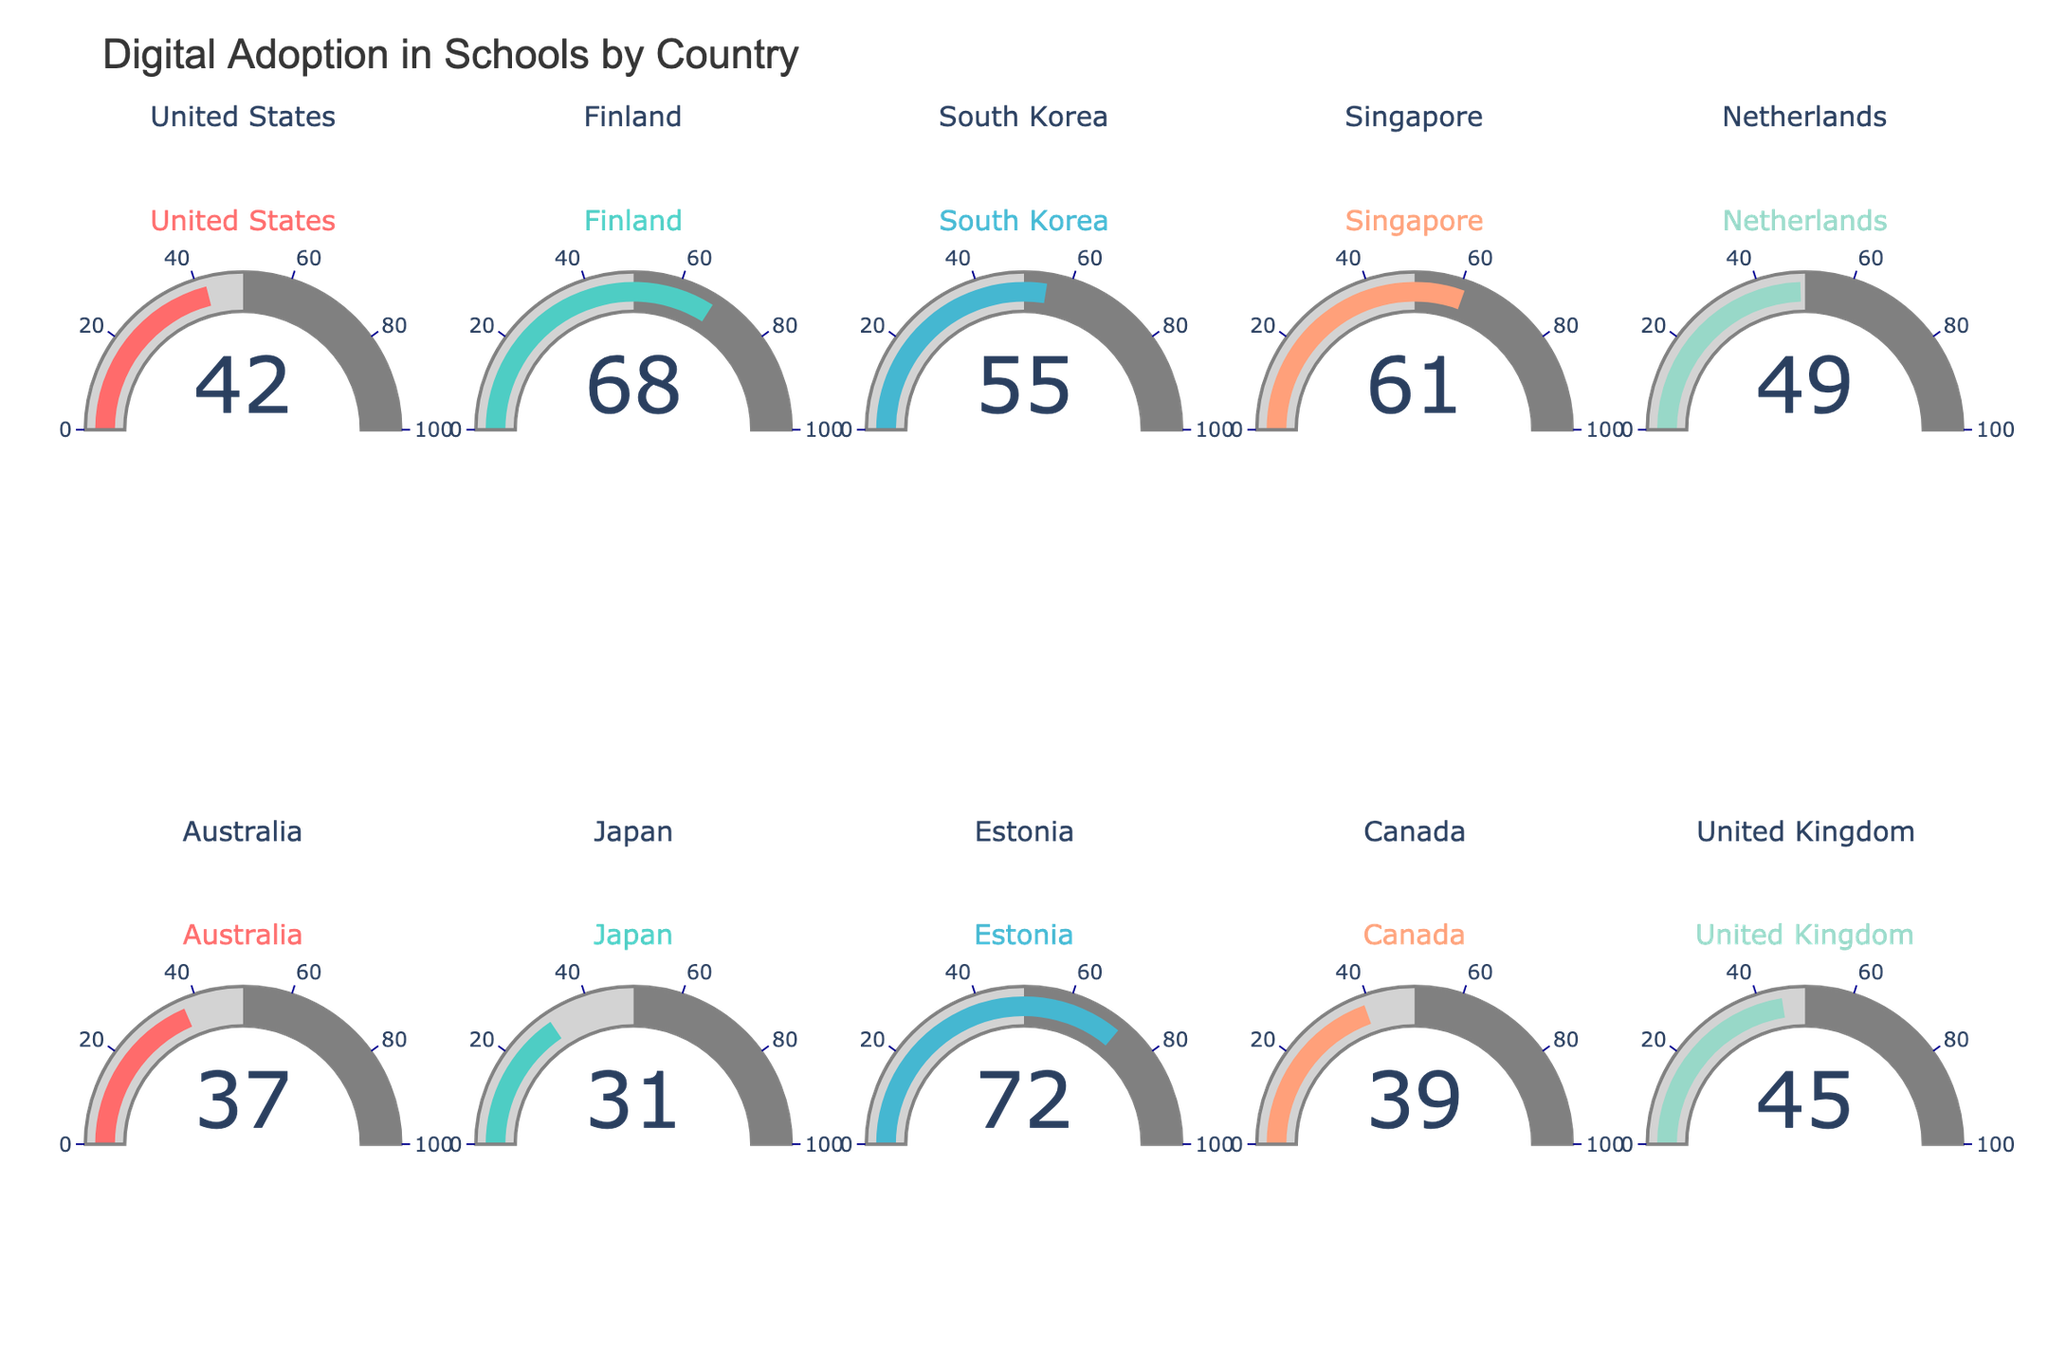What is the percentage of digital adoption in Finland? Look at the gauge for Finland in the figure. The gauge shows the number directly.
Answer: 68% How many countries have more than 50% digital adoption? Identify all countries with a gauge value over 50. Count them: Finland (68), South Korea (55), Singapore (61), Estonia (72). Total = 4
Answer: 4 Which country has the lowest digital adoption rate? Compare values on all gauges. The country with the lowest value is Japan with 31%.
Answer: Japan What is the average digital adoption rate among all the countries? Add up all the digital adoption rates and divide by 10 (total number of countries). (42 + 68 + 55 + 61 + 49 + 37 + 31 + 72 + 39 + 45) / 10 = 499 / 10 = 49.9
Answer: 49.9 Which country has a digital adoption rate closest to 40%? Look at the gauges for values close to 40. Canada has 39%, which is the nearest value.
Answer: Canada What is the difference between the highest and lowest digital adoption rates? Identify highest (Estonia, 72%) and lowest (Japan, 31%). Subtract the two values. 72 - 31 = 41
Answer: 41 How many countries are below the global average rate of digital adoption (49.9%)? Count countries with values less than 49.9: Australia (37), Japan (31), Canada (39). Total = 3.
Answer: 3 Which countries have a digital adoption rate greater than 60%? Identify gauges with values above 60%. Finland (68), Singapore (61), Estonia (72).
Answer: Finland, Singapore, Estonia What is the total sum of digital adoption rates for all countries in the dataset? Sum all the values directly from gauges. (42 + 68 + 55 + 61 + 49 + 37 + 31 + 72 + 39 + 45) = 499
Answer: 499 